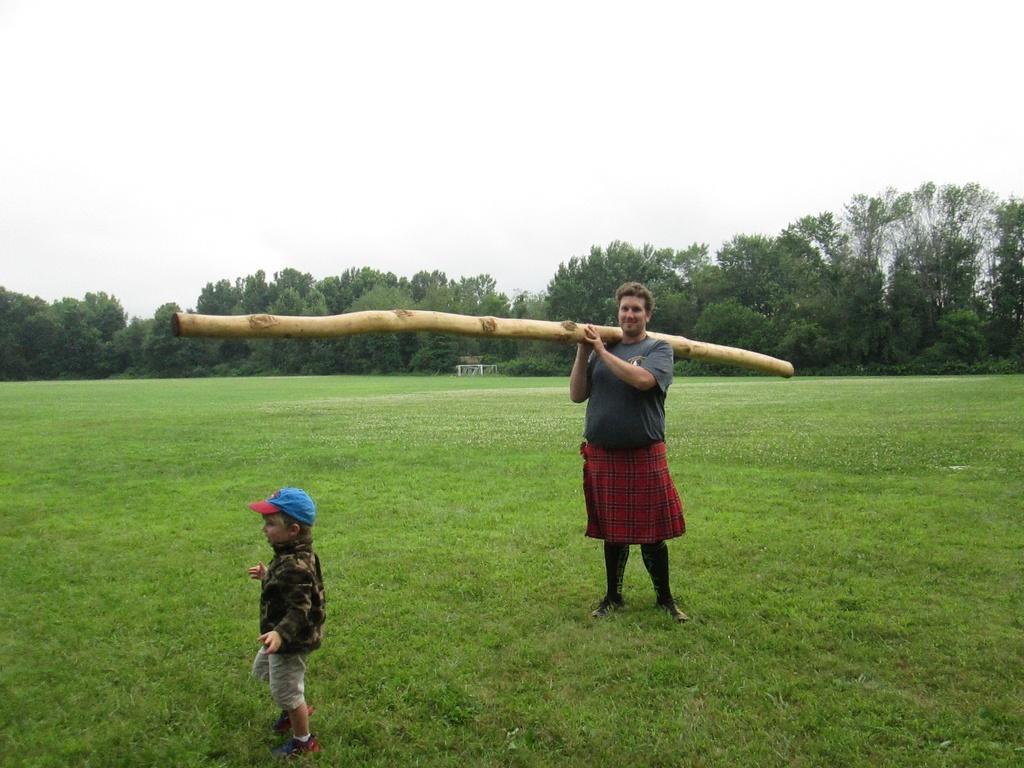How would you summarize this image in a sentence or two? In this image, we can see a person wearing clothes and holding a wooden pole on his shoulder. There is a kid at the bottom of the image. There are trees in the middle of the image. There is a grass on the ground. There is a sky at the top of the image. 